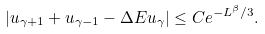Convert formula to latex. <formula><loc_0><loc_0><loc_500><loc_500>| u _ { \gamma + 1 } + u _ { \gamma - 1 } - \Delta E u _ { \gamma } | \leq C e ^ { - L ^ { \beta } / 3 } .</formula> 